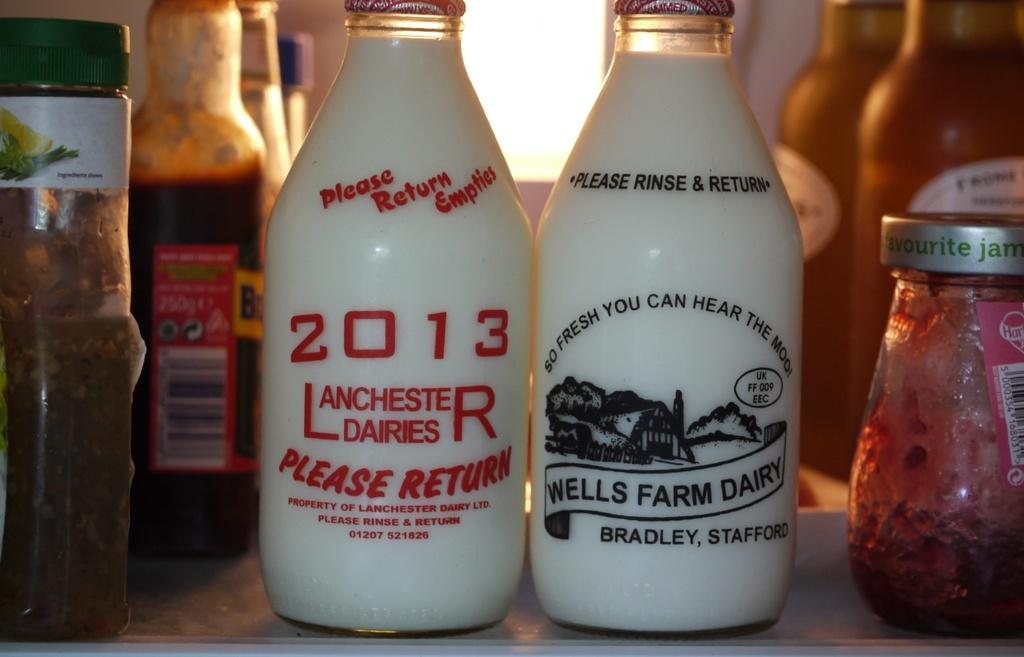<image>
Create a compact narrative representing the image presented. White bottles with 2013 Lanchester Dairies printed in Red 